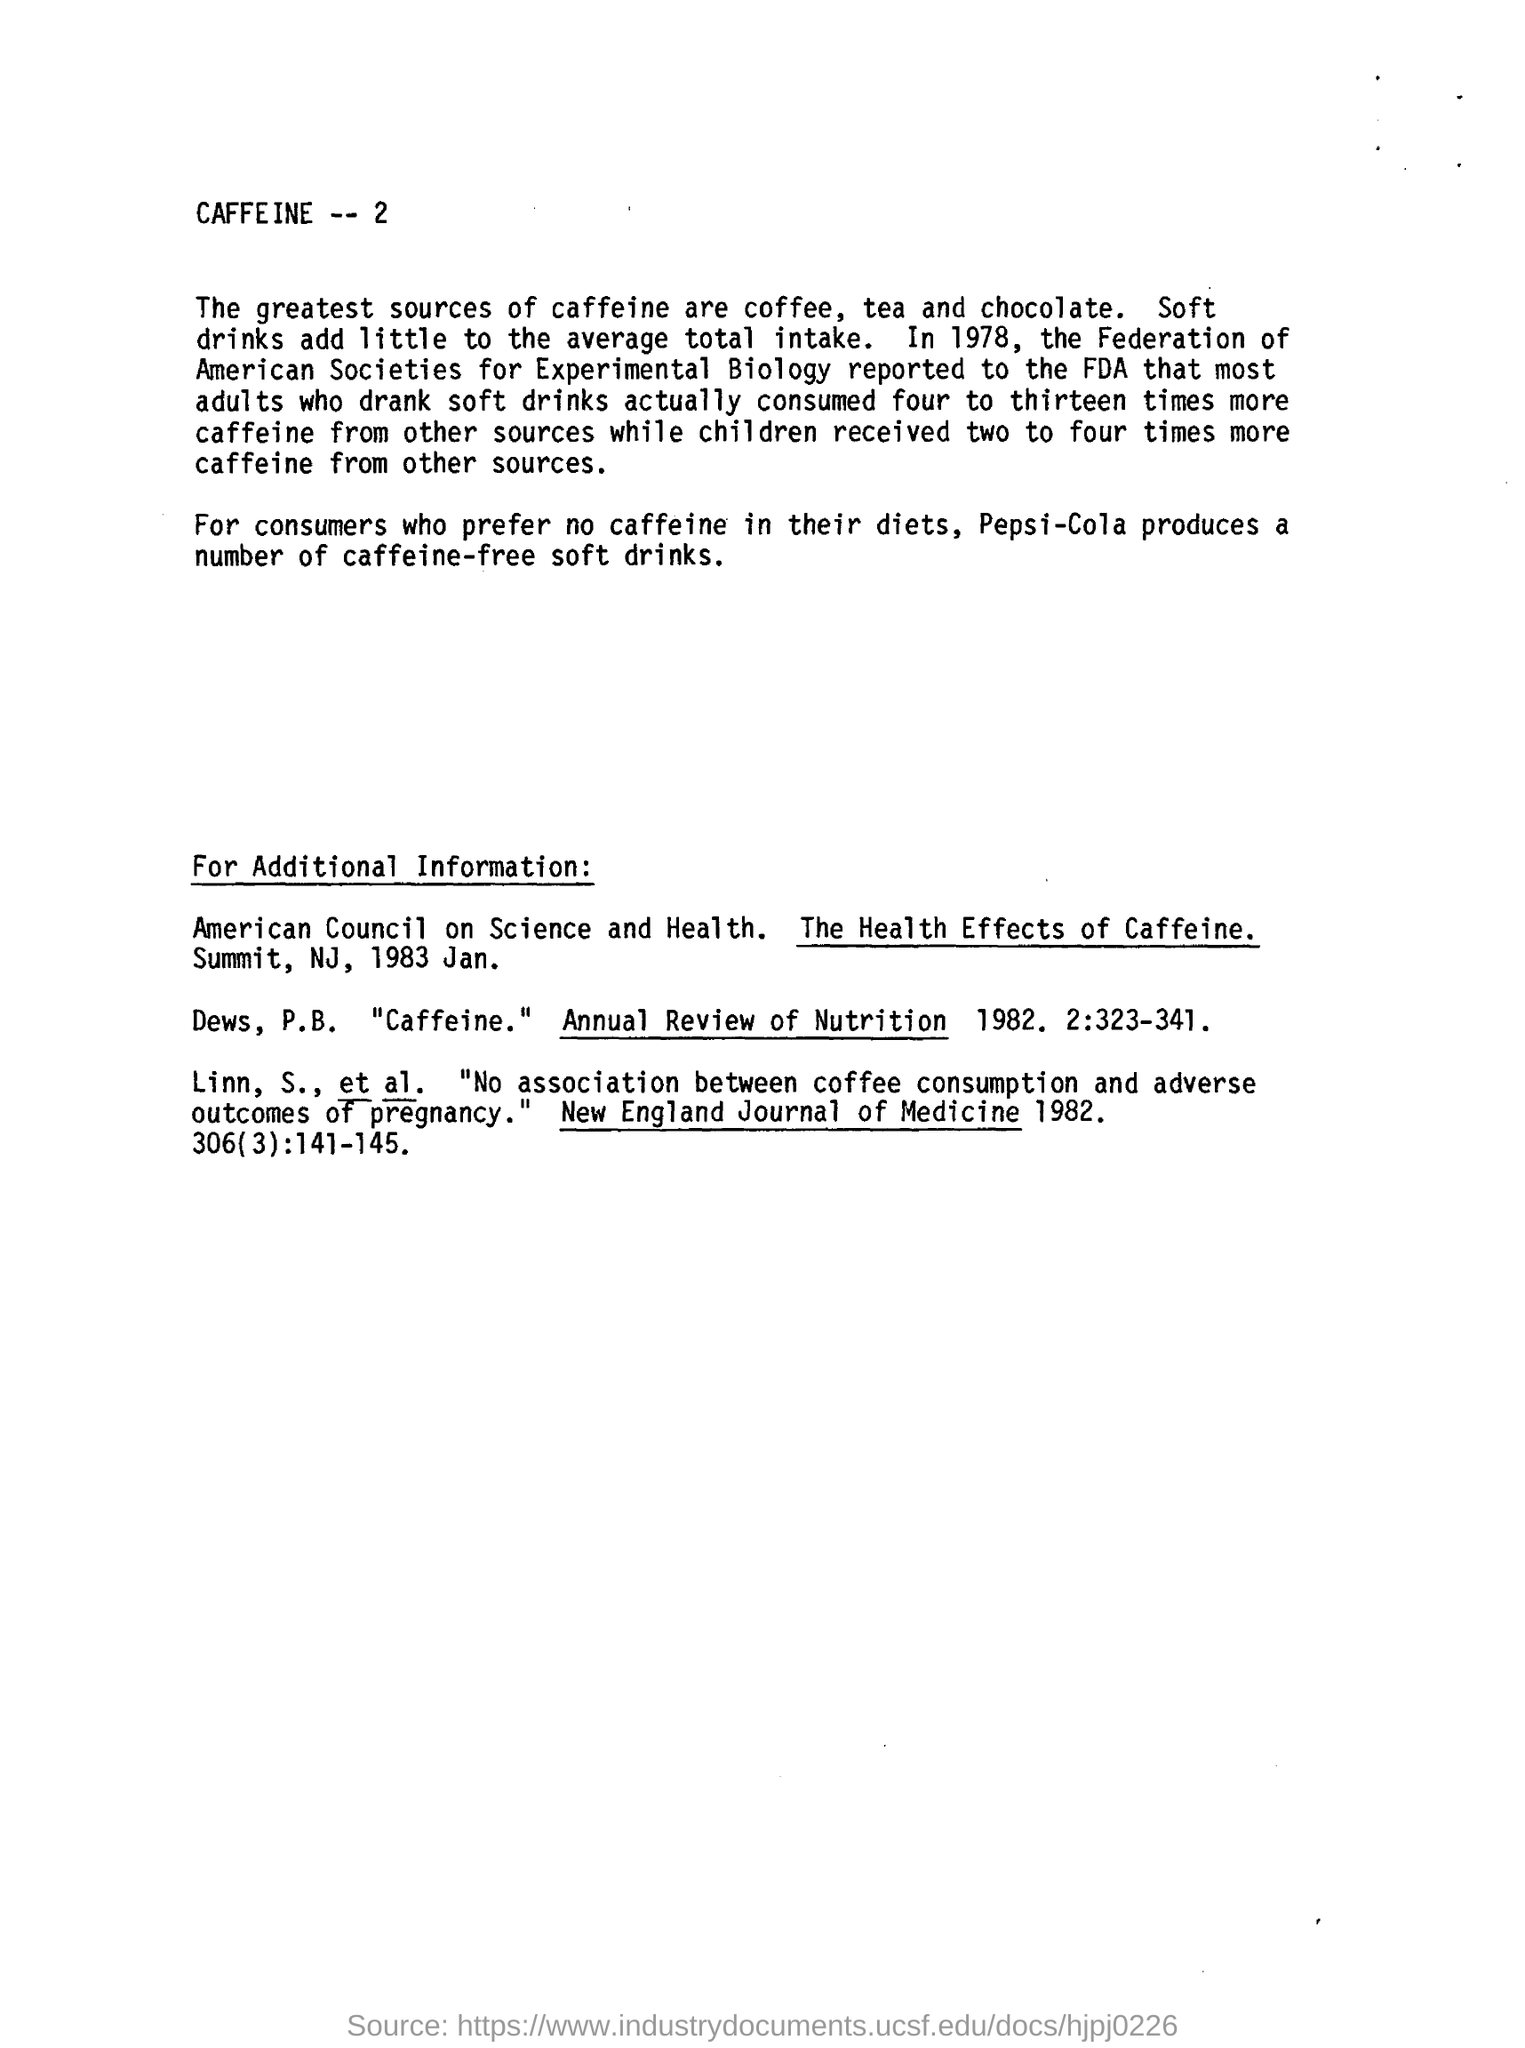Can you tell me more about the health effects of caffeine mentioned in this document? The document briefly references two sources on the health effects of caffeine. The American Council on Science and Health's report, dated January 1983, likely offers a comprehensive review of caffeine's implications on health. The New England Journal of Medicine's 1982 article seems to specifically discuss the lack of association between coffee consumption and adverse outcomes of pregnancy. These suggest that there has been significant research on caffeine's impact, but for more detailed information, one would need to review these reports directly. 